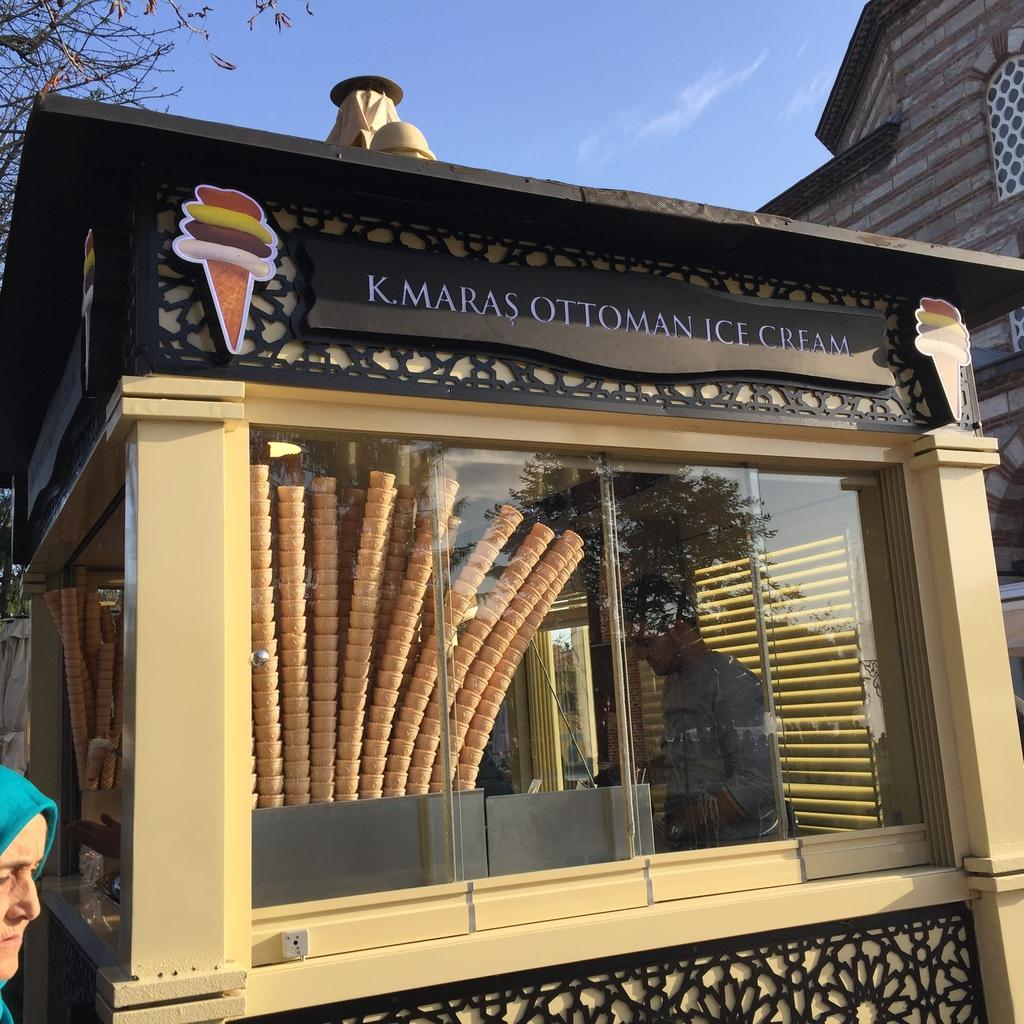What is the color of the sky in the image? The sky is blue in the image. What type of establishment is depicted in the image? The image depicts an ice-cream store. What type of ice-cream product can be seen in the image? There are ice-cream cones visible in the image. Can you describe the person inside the ice-cream store? There is a man inside the ice-cream store. What other objects or features can be seen in the image? A tree and a building with a window are visible in the image. Reasoning: Let'g: Let's think step by step in order to produce the conversation. We start by identifying the color of the sky, which is blue. Then, we describe the main subject of the image, which is an ice-cream store. Next, we mention the specific ice-cream product that can be seen, which are ice-cream cones. We then acknowledge the presence of a person inside the store, and finally, we describe other objects or features visible in the image, such as a tree and a building with a window. Absurd Question/Answer: What type of silverware is being used to eat the ice cream in the image? There is no silverware visible in the image; only ice-cream cones are present. Can you describe the clouds in the image? There are no clouds visible in the image; the sky is blue. What type of quilt is being used to cover the ice-cream cones in the image? There is no quilt present in the image; the ice-cream cones are not covered. What type of silverware is being used to eat the ice cream in the image? There is no silverware visible in the image; only ice-cream cones are present. Can you describe the clouds in the image? There are no clouds visible in the image; the sky is blue. What type of quilt is being used to cover the ice-cream cones in the image? There is no quilt present in the image; the ice-cream cones are not covered. 